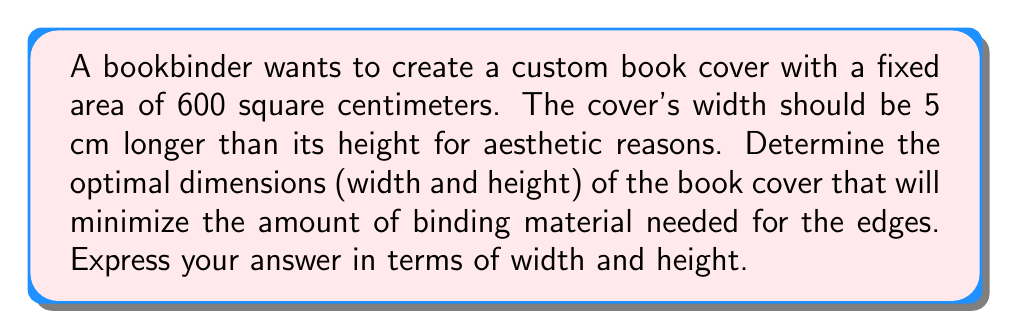Could you help me with this problem? Let's approach this step-by-step:

1) Let $h$ represent the height of the book cover and $w$ represent the width.

2) Given that the width is 5 cm longer than the height:
   $w = h + 5$

3) The area of the cover is fixed at 600 cm²:
   $A = w \times h = 600$
   $(h + 5) \times h = 600$
   $h^2 + 5h = 600$

4) The amount of binding material needed for the edges is represented by the perimeter:
   $P = 2w + 2h = 2(h + 5) + 2h = 4h + 10$

5) To minimize the perimeter, we need to find the minimum value of $h$ that satisfies the area equation. We can do this by using the quadratic formula on $h^2 + 5h - 600 = 0$:

   $h = \frac{-5 \pm \sqrt{5^2 - 4(1)(-600)}}{2(1)} = \frac{-5 \pm \sqrt{2425}}{2}$

6) Since we're dealing with physical dimensions, we only consider the positive solution:
   $h = \frac{-5 + \sqrt{2425}}{2} \approx 20$ cm

7) We can now calculate the width:
   $w = h + 5 \approx 25$ cm

8) To verify, let's check the area: $20 \times 25 = 500$ cm²

Therefore, the optimal dimensions are approximately 20 cm for height and 25 cm for width.
Answer: Height: $h \approx 20$ cm, Width: $w \approx 25$ cm 